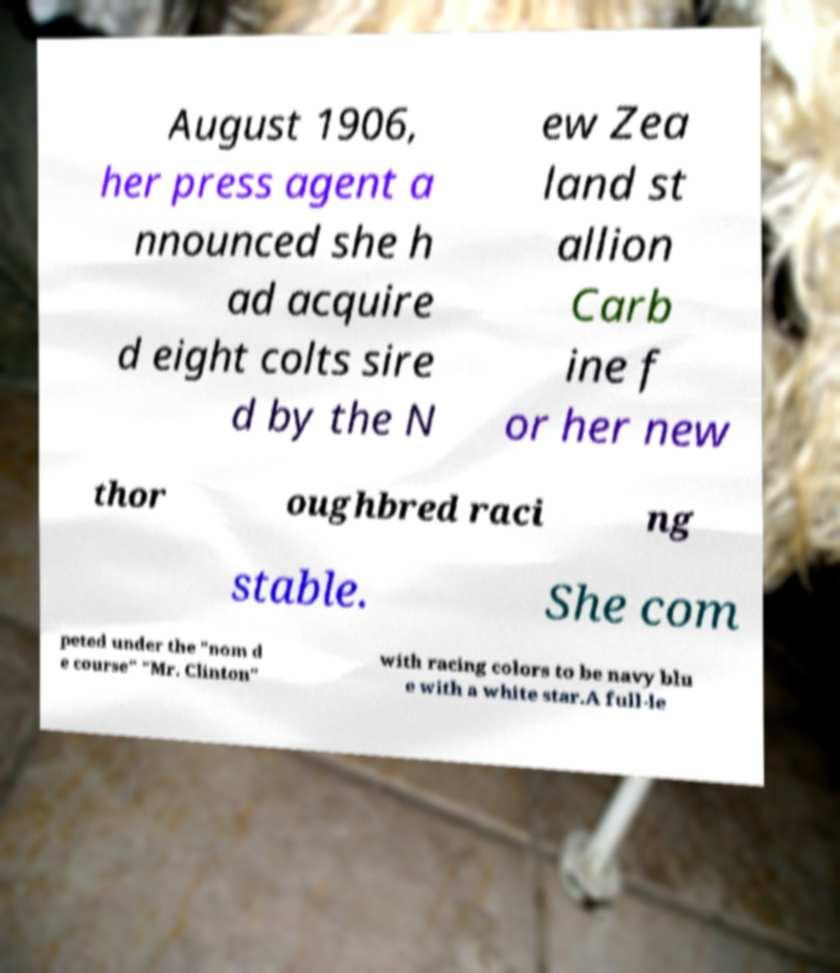Could you assist in decoding the text presented in this image and type it out clearly? August 1906, her press agent a nnounced she h ad acquire d eight colts sire d by the N ew Zea land st allion Carb ine f or her new thor oughbred raci ng stable. She com peted under the "nom d e course" "Mr. Clinton" with racing colors to be navy blu e with a white star.A full-le 